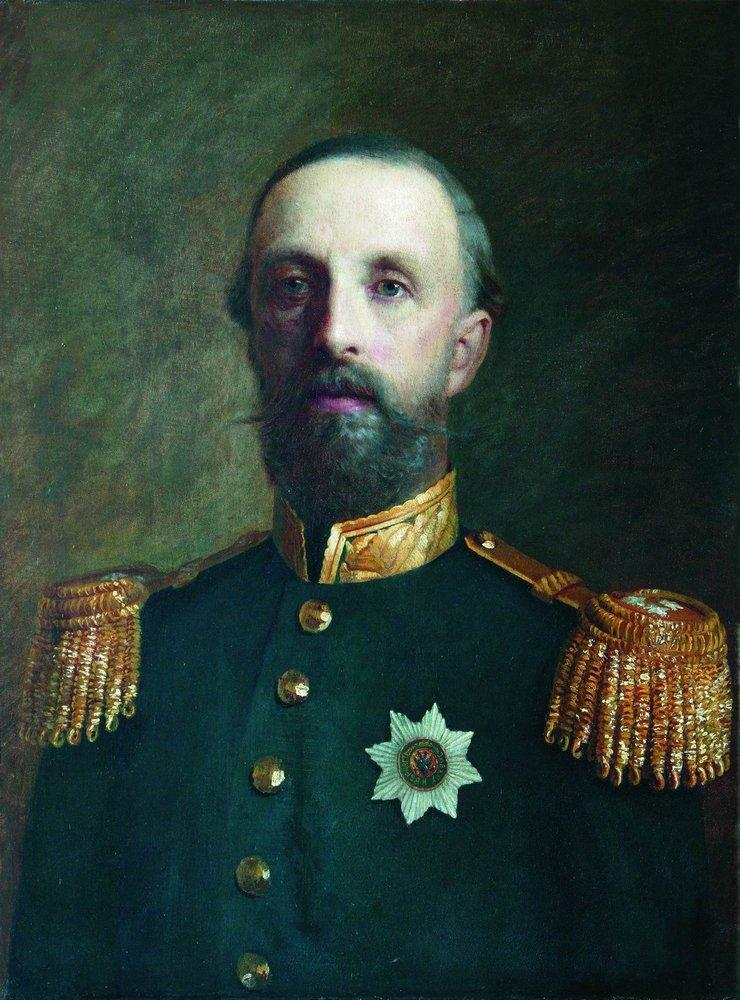What would his reflection in a magic mirror reveal about his true character? Should he gaze into a magic mirror, his reflection would reveal the very essence of his character: a man of unwavering principles, bound by honor and duty. The mirror would show not only the brave soldier seen by the world but also the compassionate heart that mourned every loss under his command. It would uncover the inner battles he fought, the moral dilemmas that plagued him, and the enduring hope that fueled his resolve. The reflection would be a mosaic of bravery, leadership, and the personal sacrifices made for the greater good—a soul carrying the weight of generations, standing as a beacon of resilience and fortitude. 